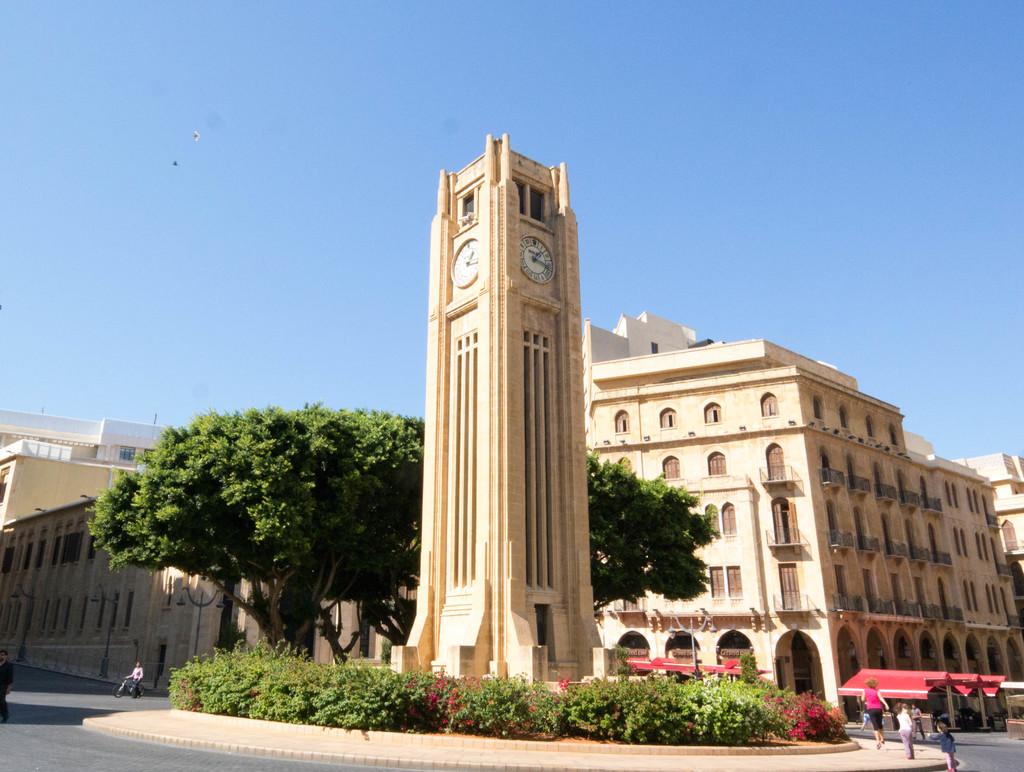What time is on the clocktower?
Make the answer very short. 1:15. 